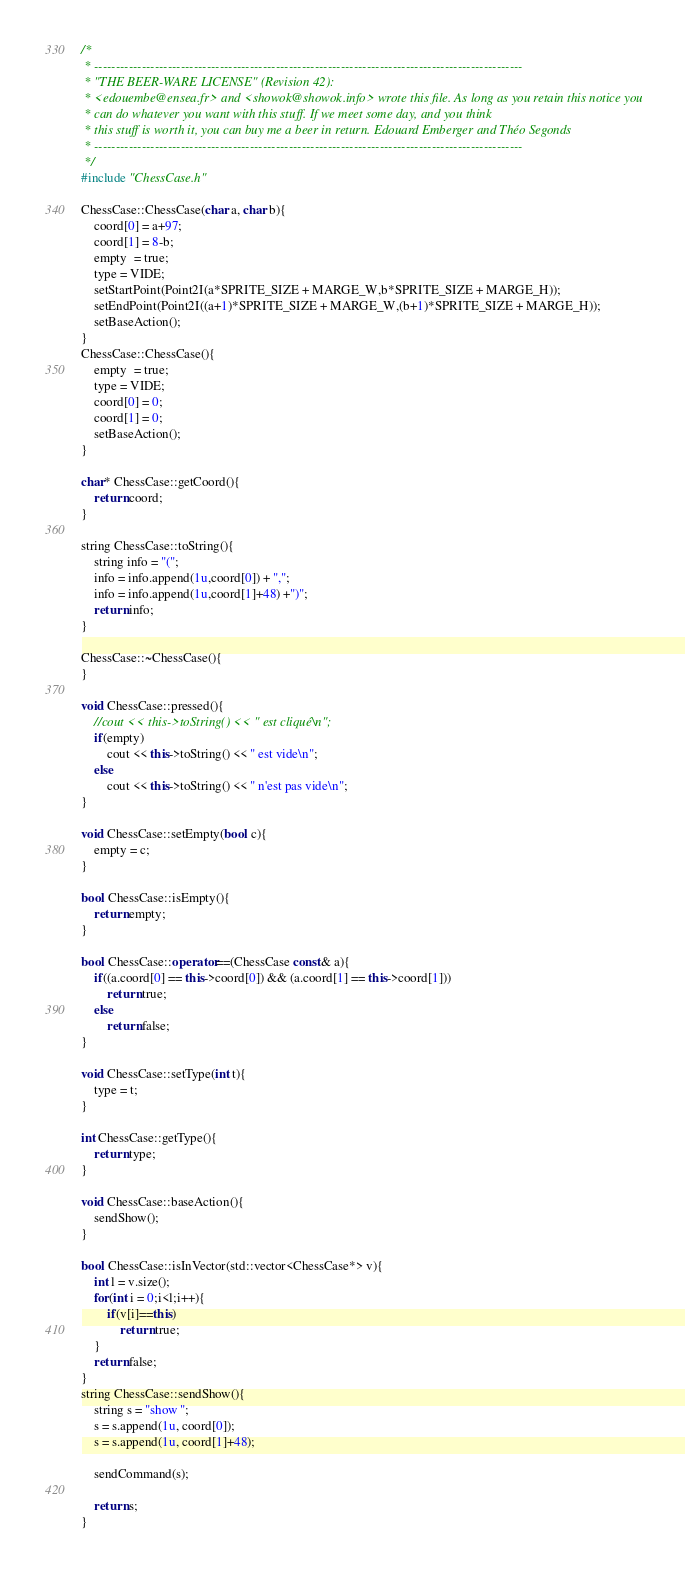<code> <loc_0><loc_0><loc_500><loc_500><_C++_>/*
 * ---------------------------------------------------------------------------------------------------
 * "THE BEER-WARE LICENSE" (Revision 42):
 * <edouembe@ensea.fr> and <showok@showok.info> wrote this file. As long as you retain this notice you
 * can do whatever you want with this stuff. If we meet some day, and you think
 * this stuff is worth it, you can buy me a beer in return. Edouard Emberger and Théo Segonds
 * ---------------------------------------------------------------------------------------------------
 */
#include "ChessCase.h"

ChessCase::ChessCase(char a, char b){
	coord[0] = a+97;
	coord[1] = 8-b;
	empty  = true;
	type = VIDE;
	setStartPoint(Point2I(a*SPRITE_SIZE + MARGE_W,b*SPRITE_SIZE + MARGE_H));
	setEndPoint(Point2I((a+1)*SPRITE_SIZE + MARGE_W,(b+1)*SPRITE_SIZE + MARGE_H));
	setBaseAction();
}
ChessCase::ChessCase(){
	empty  = true;
	type = VIDE;
	coord[0] = 0;
	coord[1] = 0;
	setBaseAction();
}

char* ChessCase::getCoord(){
	return coord;
}

string ChessCase::toString(){
	string info = "(";
	info = info.append(1u,coord[0]) + ",";
	info = info.append(1u,coord[1]+48) +")";
	return info;
}

ChessCase::~ChessCase(){
}

void ChessCase::pressed(){
	//cout << this->toString() << " est cliqué\n";
	if(empty)
		cout << this->toString() << " est vide\n";
	else
		cout << this->toString() << " n'est pas vide\n";
}

void ChessCase::setEmpty(bool c){
	empty = c;
}

bool ChessCase::isEmpty(){
	return empty;
}

bool ChessCase::operator==(ChessCase const& a){
	if((a.coord[0] == this->coord[0]) && (a.coord[1] == this->coord[1]))
		return true;
	else
		return false;
}

void ChessCase::setType(int t){
	type = t;
}

int ChessCase::getType(){
	return type;
}

void ChessCase::baseAction(){
	sendShow();
}

bool ChessCase::isInVector(std::vector<ChessCase*> v){
	int l = v.size();
	for(int i = 0;i<l;i++){
		if(v[i]==this)
			return true;
	}
	return false;
}
string ChessCase::sendShow(){
	string s = "show ";
	s = s.append(1u, coord[0]);
	s = s.append(1u, coord[1]+48);

	sendCommand(s);

	return s;
}
</code> 